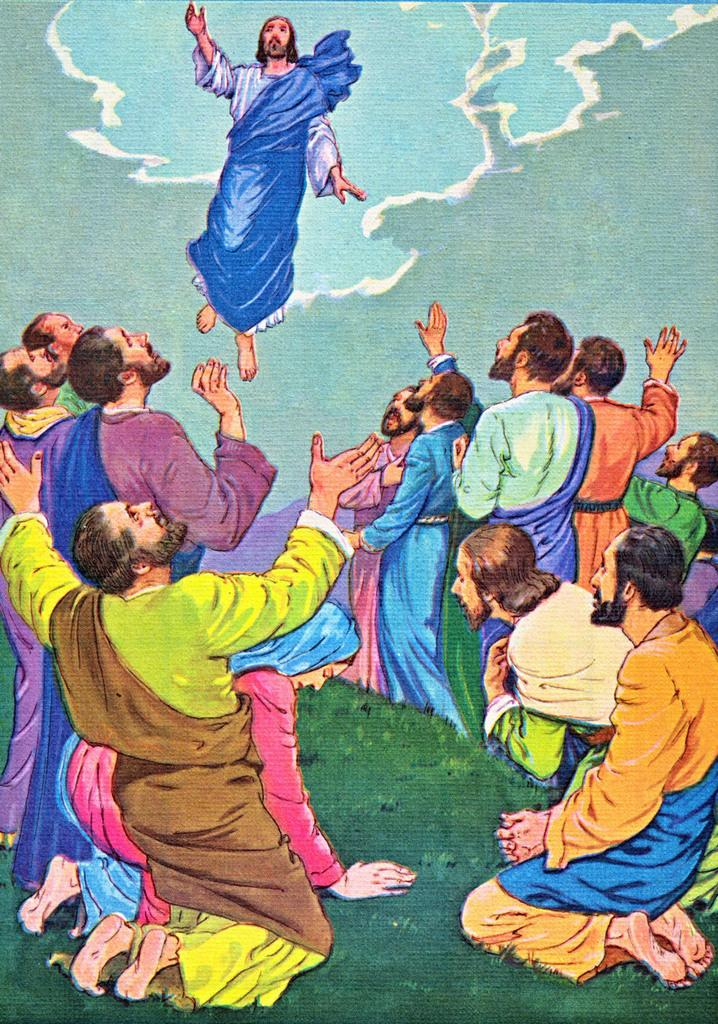What is the main subject of the painting in the image? There is a painting of Jesus in the image. Are there any other figures or elements in the painting? Yes, there are people depicted in the painting. What can be seen in the background of the painting? There is a sky visible in the background of the image. What language is spoken by the woman in the painting? There is no woman present in the painting, and therefore no language can be attributed to her. 